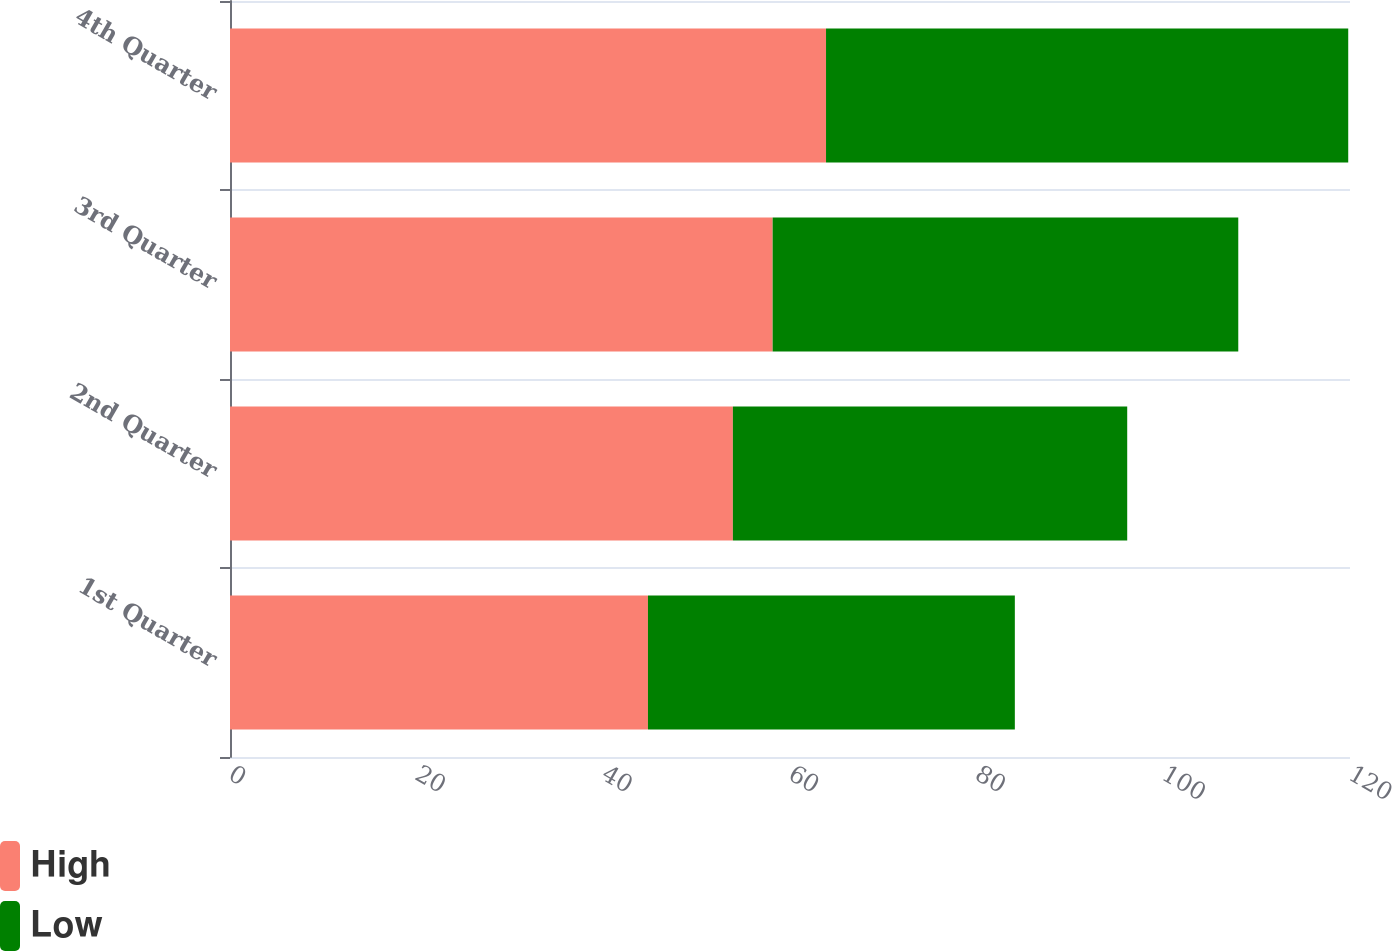<chart> <loc_0><loc_0><loc_500><loc_500><stacked_bar_chart><ecel><fcel>1st Quarter<fcel>2nd Quarter<fcel>3rd Quarter<fcel>4th Quarter<nl><fcel>High<fcel>44.78<fcel>53.88<fcel>58.14<fcel>63.86<nl><fcel>Low<fcel>39.31<fcel>42.25<fcel>49.89<fcel>55.95<nl></chart> 